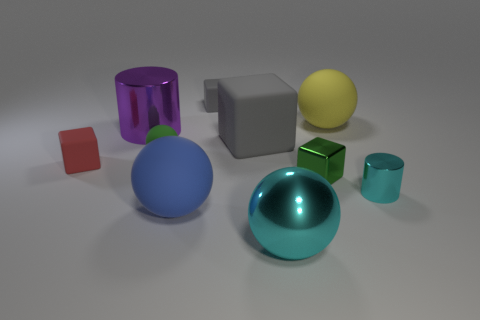What is the size of the matte thing that is the same color as the small metal cube?
Ensure brevity in your answer.  Small. What is the shape of the metallic thing that is the same color as the big metallic sphere?
Make the answer very short. Cylinder. What color is the small sphere?
Make the answer very short. Green. What shape is the large matte thing behind the gray matte thing that is in front of the big ball on the right side of the metallic cube?
Give a very brief answer. Sphere. What is the material of the tiny block that is both on the left side of the large cyan ball and in front of the large gray rubber thing?
Provide a succinct answer. Rubber. The cyan object to the right of the matte ball that is behind the large matte block is what shape?
Offer a very short reply. Cylinder. Is there any other thing of the same color as the big matte block?
Offer a very short reply. Yes. Is the size of the green block the same as the cylinder right of the small gray matte thing?
Offer a very short reply. Yes. How many tiny things are either purple things or gray things?
Your response must be concise. 1. Are there more big blue rubber cylinders than small green shiny things?
Make the answer very short. No. 